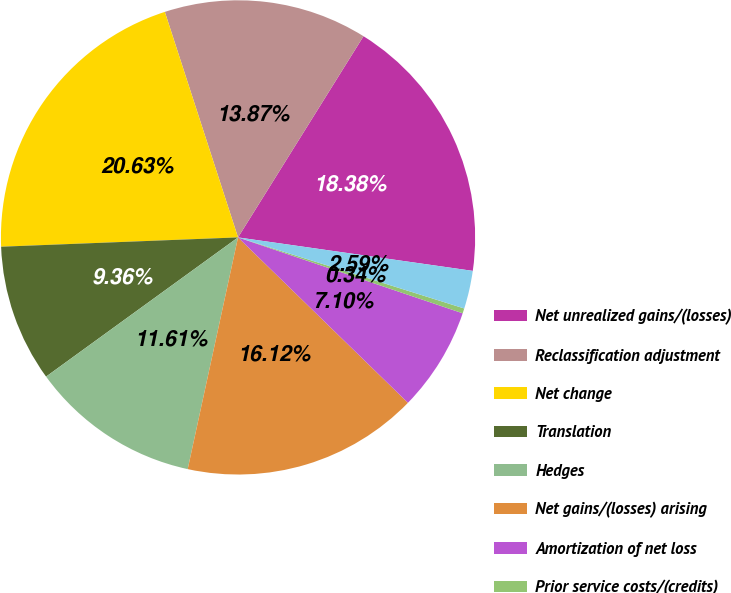Convert chart. <chart><loc_0><loc_0><loc_500><loc_500><pie_chart><fcel>Net unrealized gains/(losses)<fcel>Reclassification adjustment<fcel>Net change<fcel>Translation<fcel>Hedges<fcel>Net gains/(losses) arising<fcel>Amortization of net loss<fcel>Prior service costs/(credits)<fcel>Foreign exchange and other<nl><fcel>18.38%<fcel>13.87%<fcel>20.63%<fcel>9.36%<fcel>11.61%<fcel>16.12%<fcel>7.1%<fcel>0.34%<fcel>2.59%<nl></chart> 